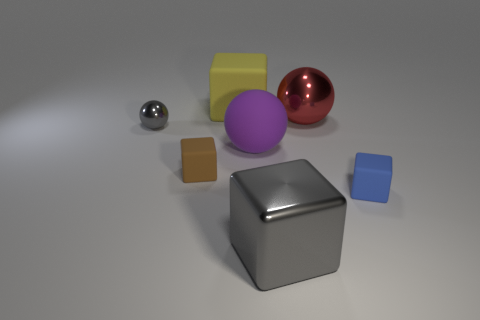Add 2 small yellow shiny cylinders. How many objects exist? 9 Subtract all blocks. How many objects are left? 3 Subtract 0 brown cylinders. How many objects are left? 7 Subtract all yellow rubber cubes. Subtract all big matte objects. How many objects are left? 4 Add 3 big purple matte things. How many big purple matte things are left? 4 Add 7 small metal balls. How many small metal balls exist? 8 